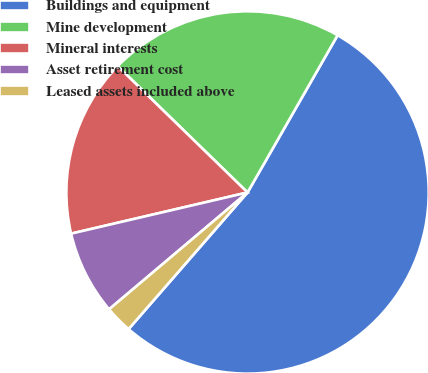Convert chart. <chart><loc_0><loc_0><loc_500><loc_500><pie_chart><fcel>Buildings and equipment<fcel>Mine development<fcel>Mineral interests<fcel>Asset retirement cost<fcel>Leased assets included above<nl><fcel>53.12%<fcel>21.0%<fcel>15.93%<fcel>7.51%<fcel>2.44%<nl></chart> 